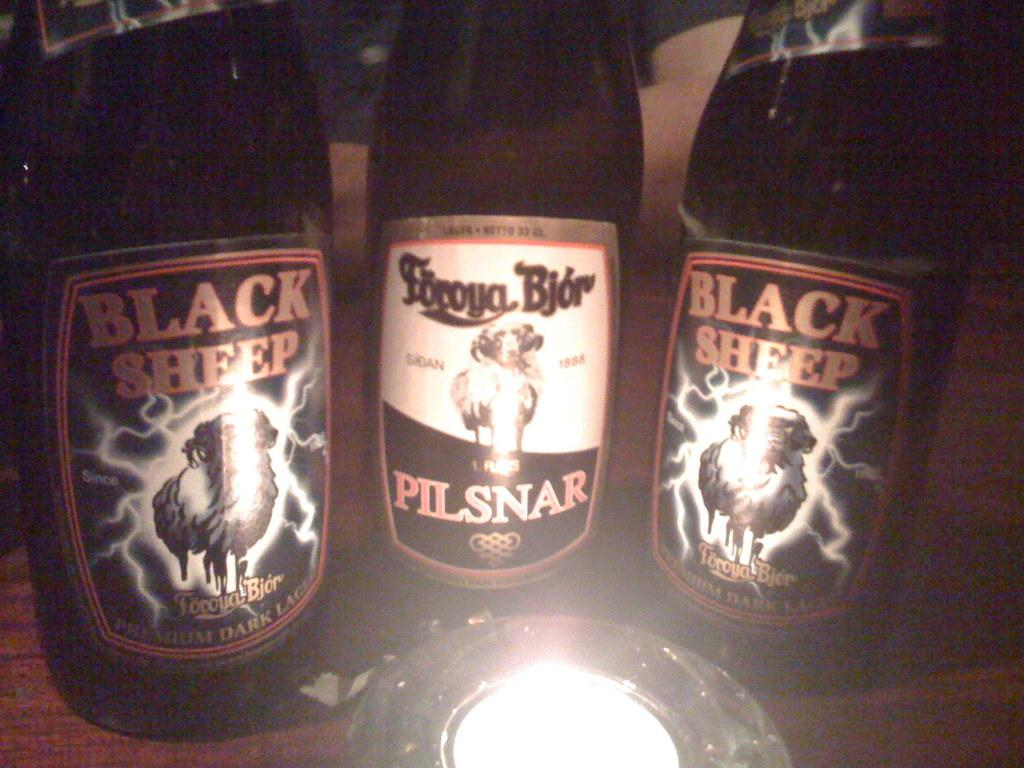<image>
Offer a succinct explanation of the picture presented. Pilsnar beer bottle between two Black Sheep beers. 